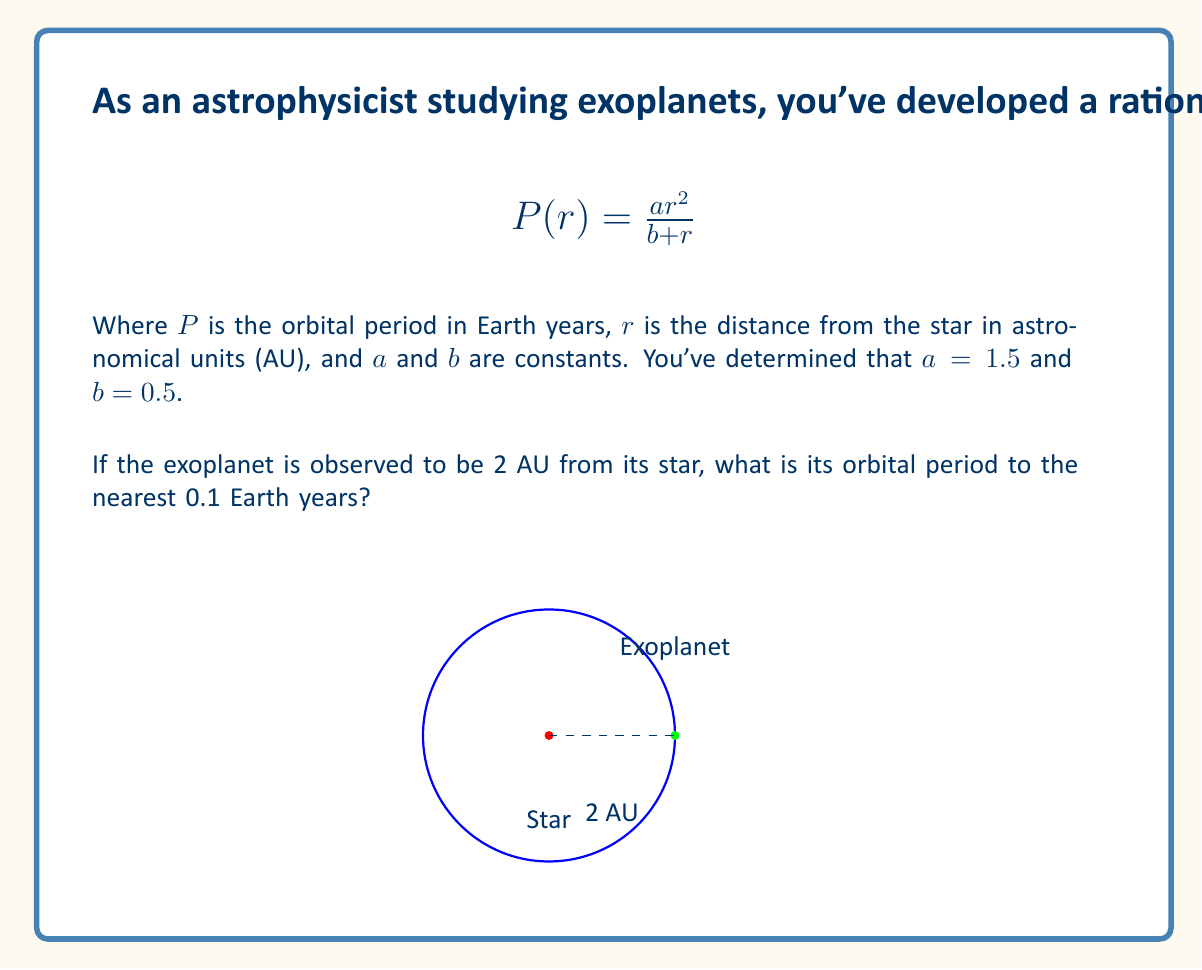Give your solution to this math problem. Let's approach this step-by-step:

1) We're given the rational function model:
   $$P(r) = \frac{ar^2}{b + r}$$

2) We know the following values:
   $a = 1.5$
   $b = 0.5$
   $r = 2$ AU

3) Let's substitute these values into our equation:
   $$P(2) = \frac{1.5 \cdot 2^2}{0.5 + 2}$$

4) Simplify the numerator:
   $$P(2) = \frac{1.5 \cdot 4}{0.5 + 2} = \frac{6}{2.5}$$

5) Perform the division:
   $$P(2) = 2.4$$

6) Rounding to the nearest 0.1 Earth years:
   $$P(2) \approx 2.4$$ Earth years

Therefore, the orbital period of the exoplanet is approximately 2.4 Earth years.
Answer: 2.4 Earth years 